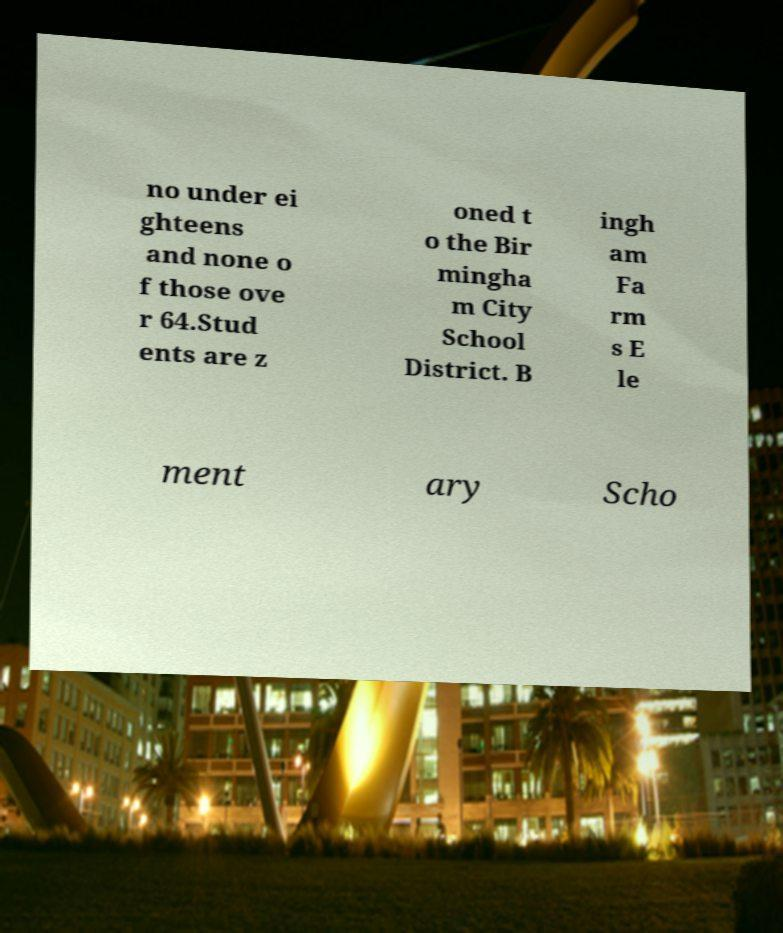Please identify and transcribe the text found in this image. no under ei ghteens and none o f those ove r 64.Stud ents are z oned t o the Bir mingha m City School District. B ingh am Fa rm s E le ment ary Scho 